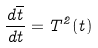<formula> <loc_0><loc_0><loc_500><loc_500>\frac { d \overline { t } } { d t } = T ^ { 2 } ( t )</formula> 